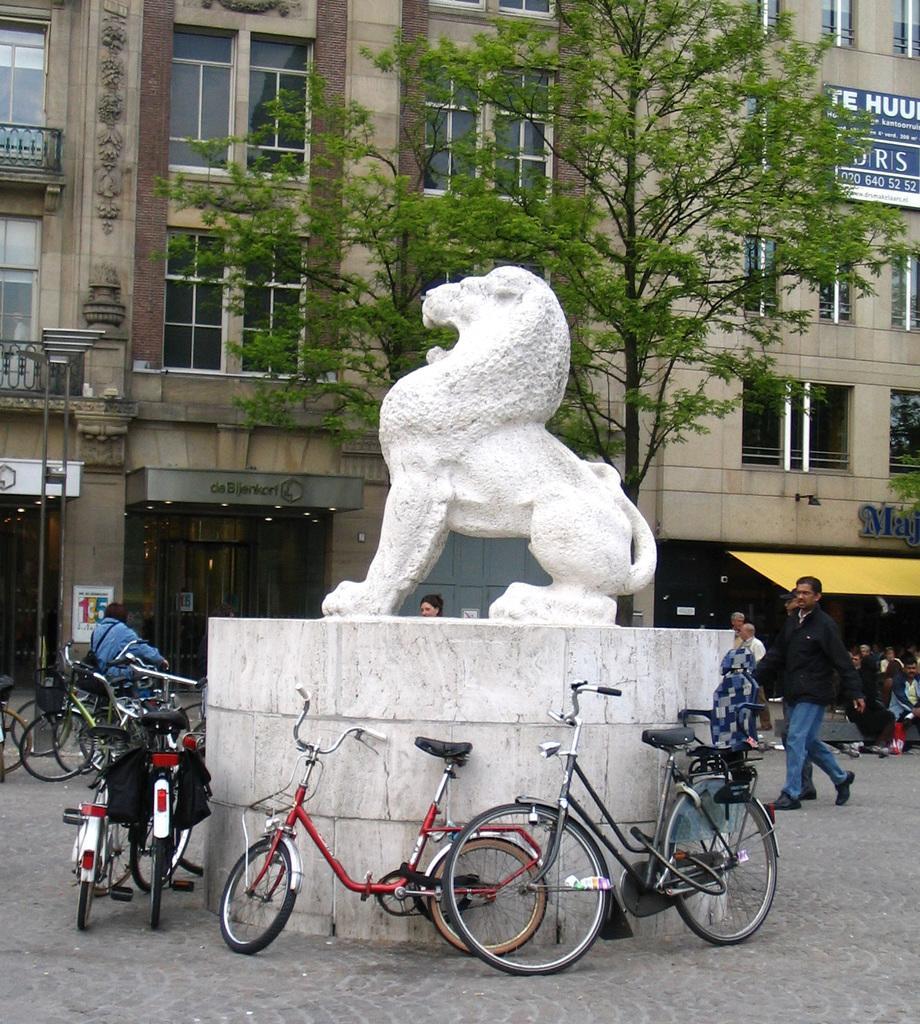Could you give a brief overview of what you see in this image? This picture is clicked outside. In the foreground we can see the bicycles parked on the ground. In the center there is a sculpture of a lion and there are some persons seems to be walking on the ground. On the left there is a person riding a bicycle. In the background we can see the building, trees and a board attached to the building on which the text is printed. 